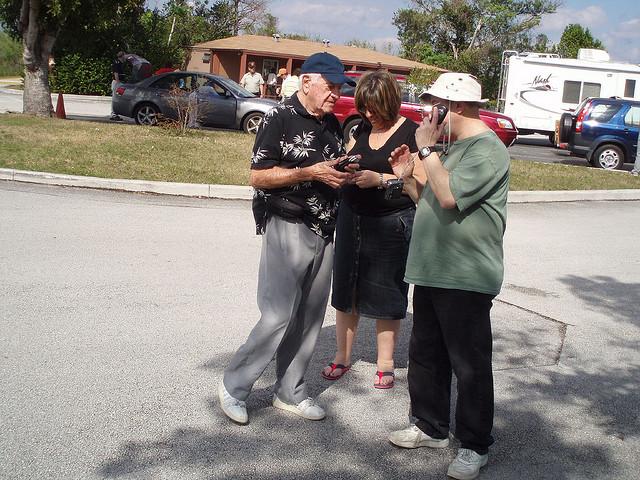What color are the lady's slippers?
Be succinct. Red and black. How many people wear sneakers?
Concise answer only. 2. What are the people looking at?
Keep it brief. Cell phone. 